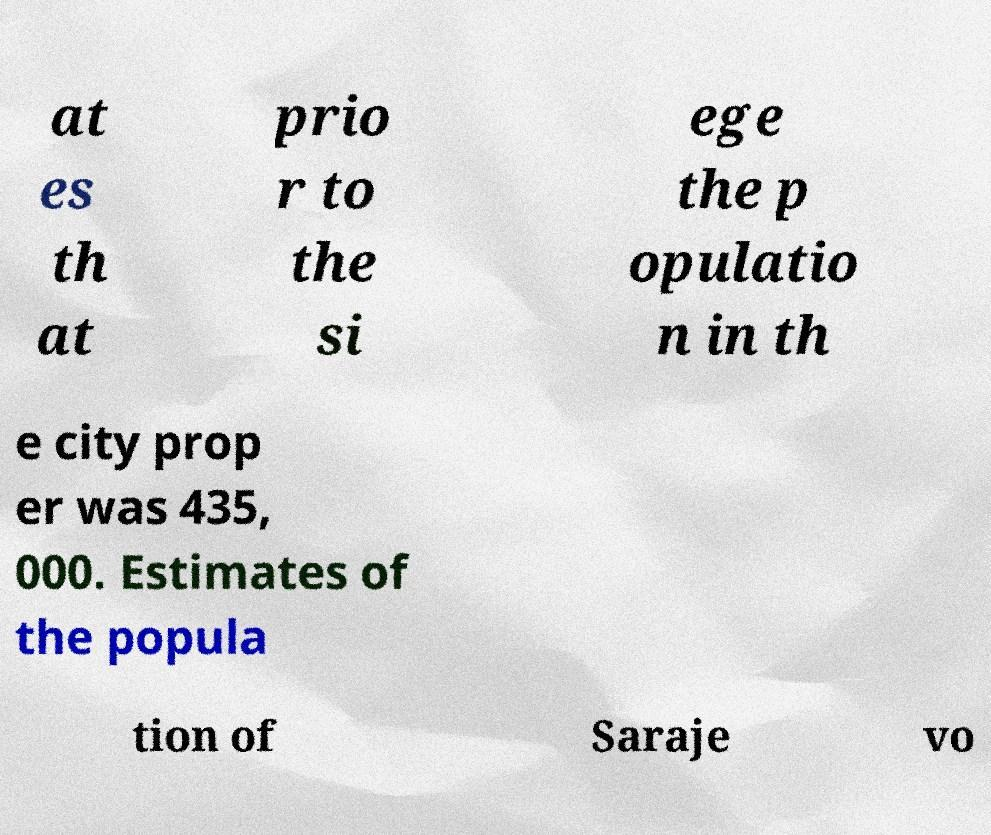Can you accurately transcribe the text from the provided image for me? at es th at prio r to the si ege the p opulatio n in th e city prop er was 435, 000. Estimates of the popula tion of Saraje vo 